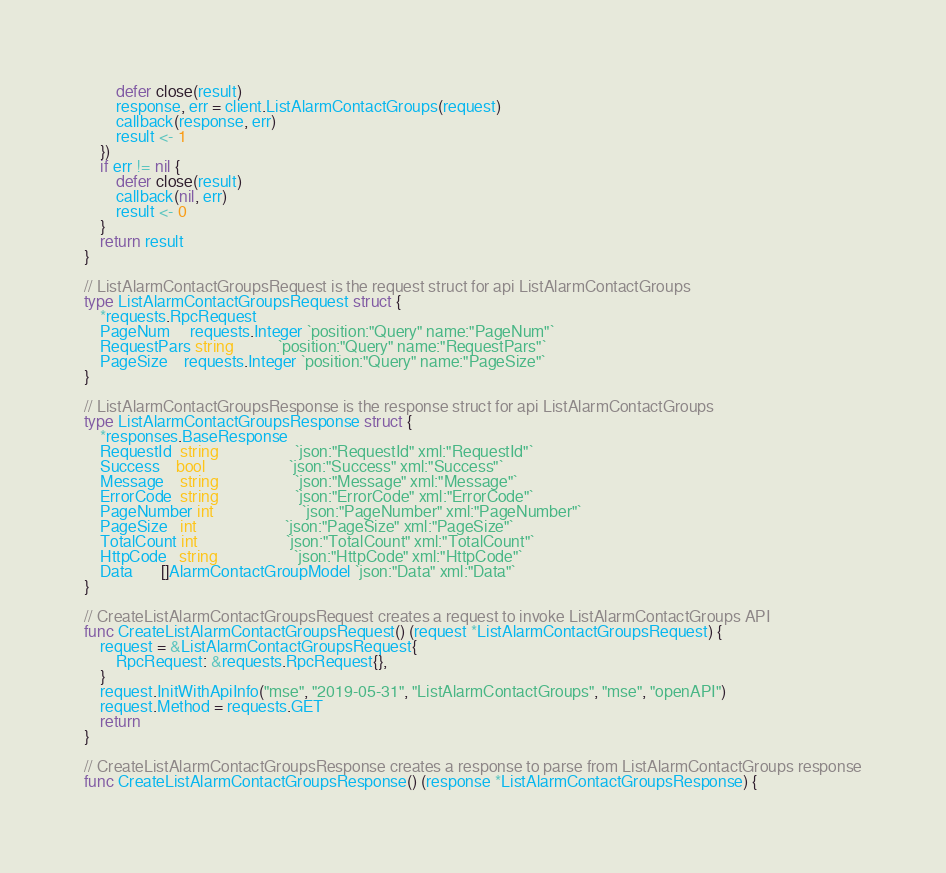Convert code to text. <code><loc_0><loc_0><loc_500><loc_500><_Go_>		defer close(result)
		response, err = client.ListAlarmContactGroups(request)
		callback(response, err)
		result <- 1
	})
	if err != nil {
		defer close(result)
		callback(nil, err)
		result <- 0
	}
	return result
}

// ListAlarmContactGroupsRequest is the request struct for api ListAlarmContactGroups
type ListAlarmContactGroupsRequest struct {
	*requests.RpcRequest
	PageNum     requests.Integer `position:"Query" name:"PageNum"`
	RequestPars string           `position:"Query" name:"RequestPars"`
	PageSize    requests.Integer `position:"Query" name:"PageSize"`
}

// ListAlarmContactGroupsResponse is the response struct for api ListAlarmContactGroups
type ListAlarmContactGroupsResponse struct {
	*responses.BaseResponse
	RequestId  string                   `json:"RequestId" xml:"RequestId"`
	Success    bool                     `json:"Success" xml:"Success"`
	Message    string                   `json:"Message" xml:"Message"`
	ErrorCode  string                   `json:"ErrorCode" xml:"ErrorCode"`
	PageNumber int                      `json:"PageNumber" xml:"PageNumber"`
	PageSize   int                      `json:"PageSize" xml:"PageSize"`
	TotalCount int                      `json:"TotalCount" xml:"TotalCount"`
	HttpCode   string                   `json:"HttpCode" xml:"HttpCode"`
	Data       []AlarmContactGroupModel `json:"Data" xml:"Data"`
}

// CreateListAlarmContactGroupsRequest creates a request to invoke ListAlarmContactGroups API
func CreateListAlarmContactGroupsRequest() (request *ListAlarmContactGroupsRequest) {
	request = &ListAlarmContactGroupsRequest{
		RpcRequest: &requests.RpcRequest{},
	}
	request.InitWithApiInfo("mse", "2019-05-31", "ListAlarmContactGroups", "mse", "openAPI")
	request.Method = requests.GET
	return
}

// CreateListAlarmContactGroupsResponse creates a response to parse from ListAlarmContactGroups response
func CreateListAlarmContactGroupsResponse() (response *ListAlarmContactGroupsResponse) {</code> 